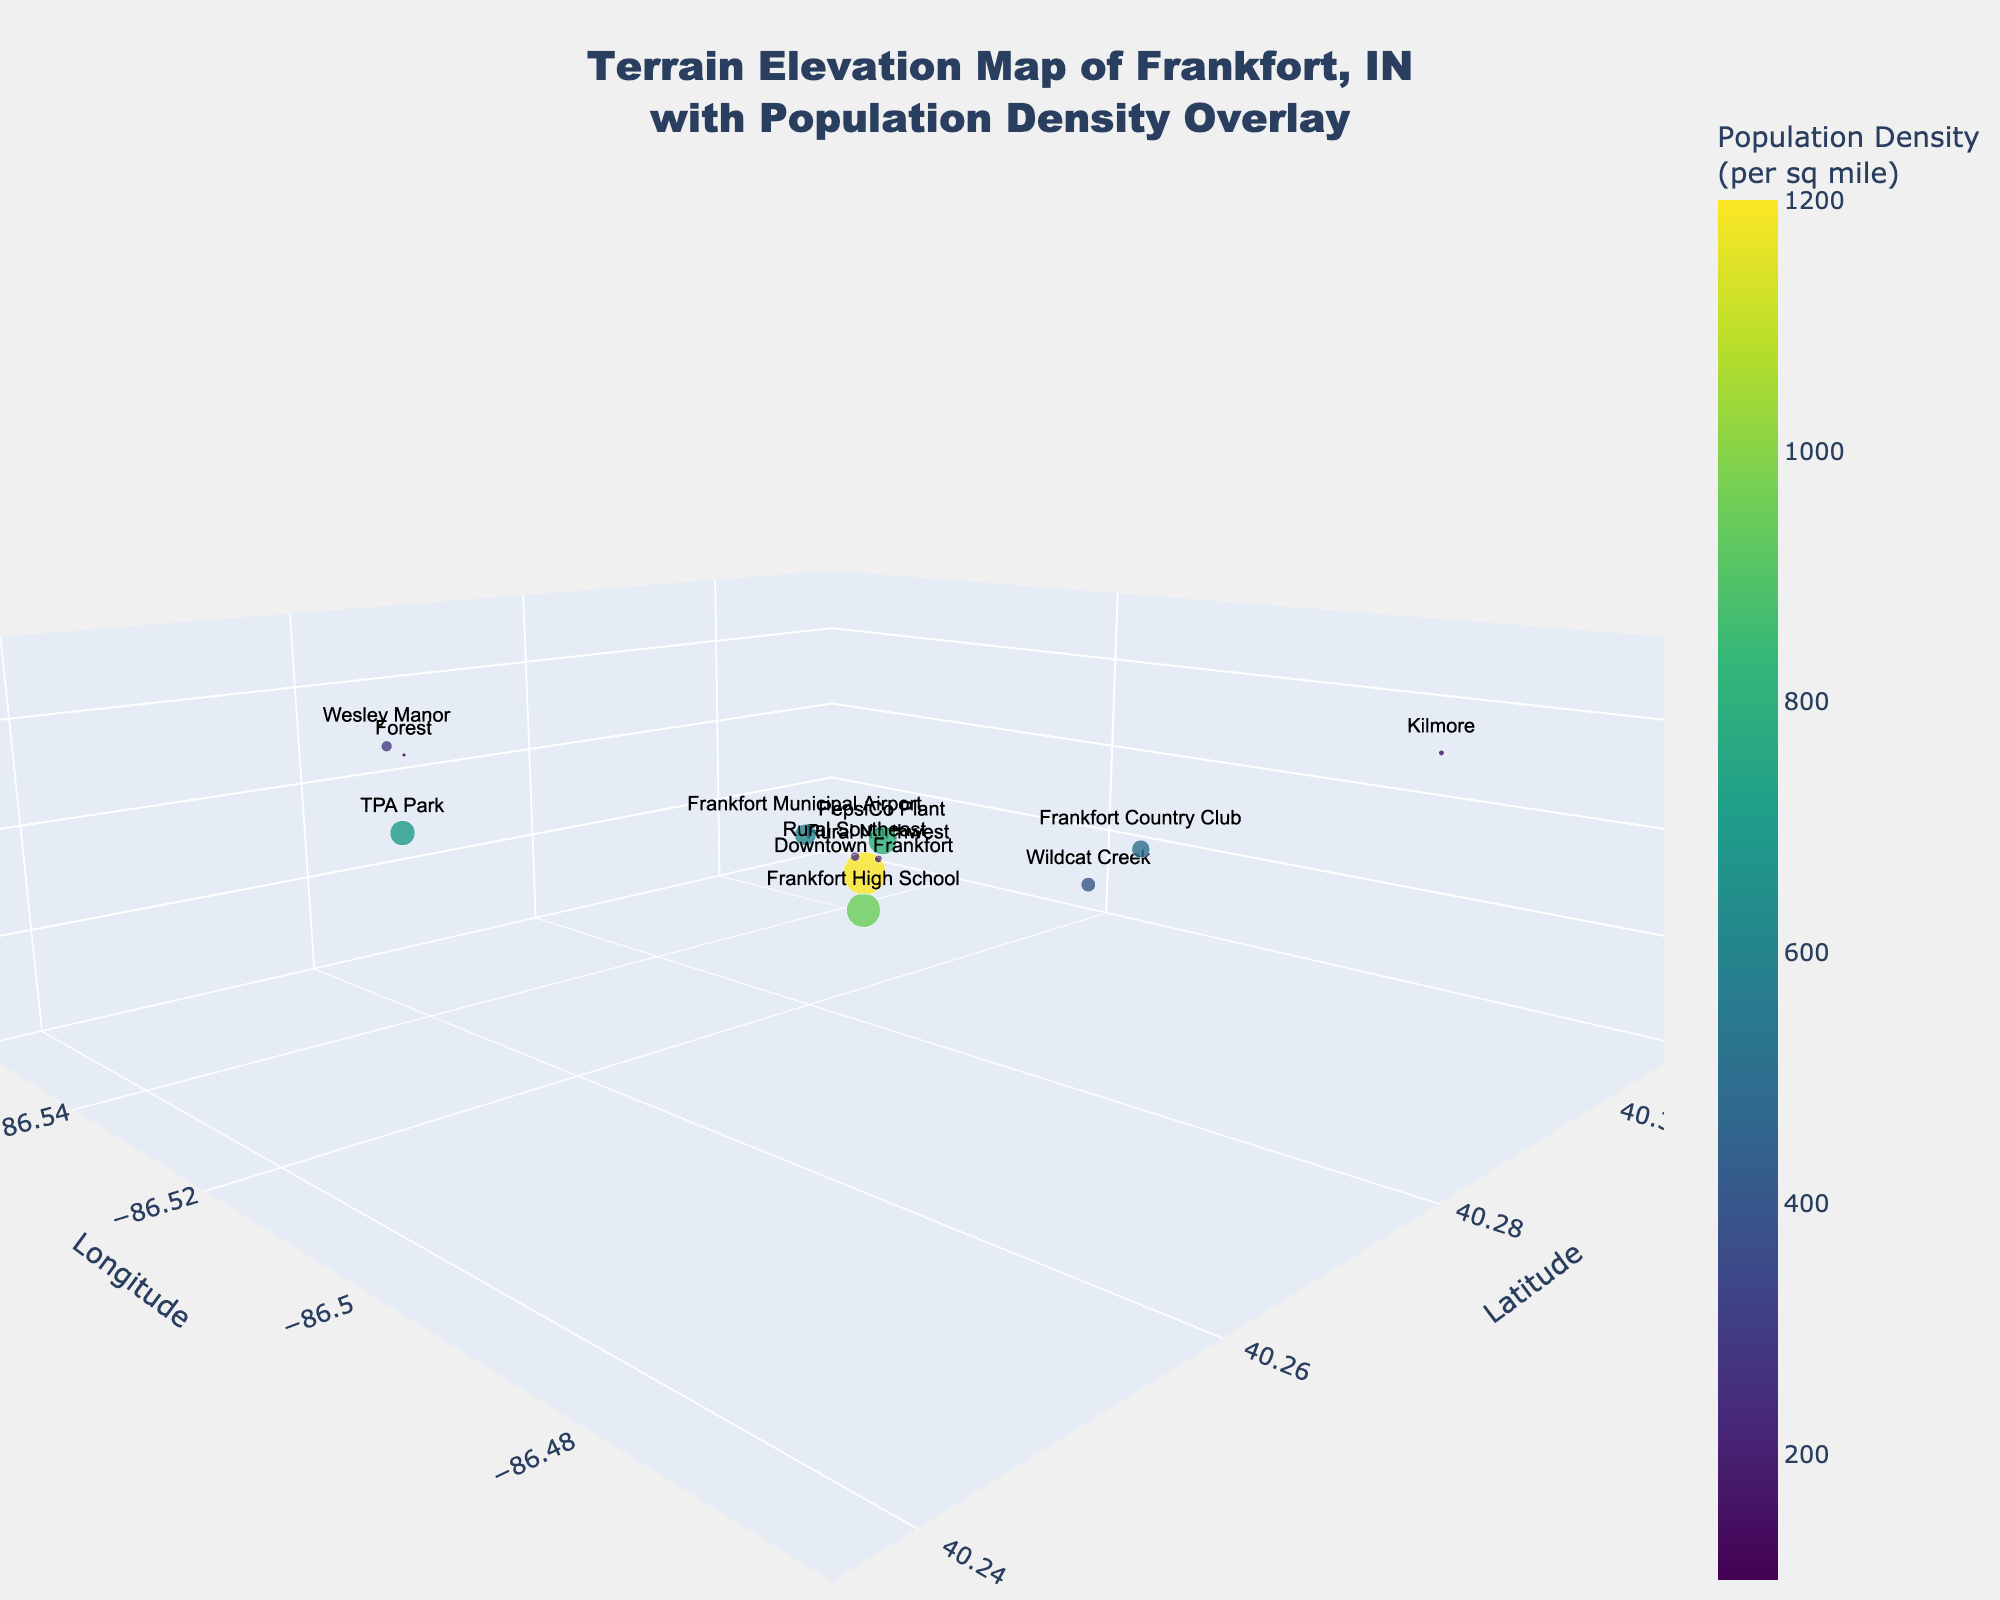What is the highest elevation shown in the plot? The highest elevation can be found by locating the data point with the maximum z value on the 3D plot. The z-axis represents elevation in feet.
Answer: 885 feet Which location has the highest population density? By examining the color scale and the marker sizes, which indicate population density, the densest population is represented by the largest and most intensely colored marker.
Answer: Downtown Frankfort What is the relationship between the elevation and population density at the Frankfort High School? To analyze the relationship, look at the specific data point for the Frankfort High School. The elevation is 855 feet, and the population density is indicated by the marker size and color.
Answer: Elevation: 855 feet, Population Density: 950 per sq mile Which location has the lowest population density, and what is its elevation? To find the location with the lowest population density, refer to the smallest and least intensely colored marker. Then check its corresponding elevation.
Answer: Kilmore, 880 feet Compare the elevation of the PepsiCo Plant and TPA Park. Which one is higher? Look at the elevation values for the PepsiCo Plant and TPA Park on the z-axis. Compare the two values directly.
Answer: TPA Park is higher What is the combined population density of Rural Northwest and Rural Southeast? To find the combined population density, look up the individual densities and then add them together: 200 (Rural Northwest) + 250 (Rural Southeast).
Answer: 450 per sq mile What is the range of elevations shown in the plot? Find the minimum and maximum elevations from the plotted data points, and then calculate their difference. The range is max elevation - min elevation.
Answer: 885 - 830 = 55 feet Which locations have an elevation below 840 feet? Review the plot for data points with a z value less than 840 feet. Identify the corresponding locations.
Answer: Frankfort Municipal Airport, Wildcat Creek, Rural Northwest How does the population density at Wesley Manor compare to Wildcat Creek? Compare the marker size and color for Wesley Manor and Wildcat Creek. The bigger and more intensely colored marker has the higher population density.
Answer: Wesley Manor has a higher population density 